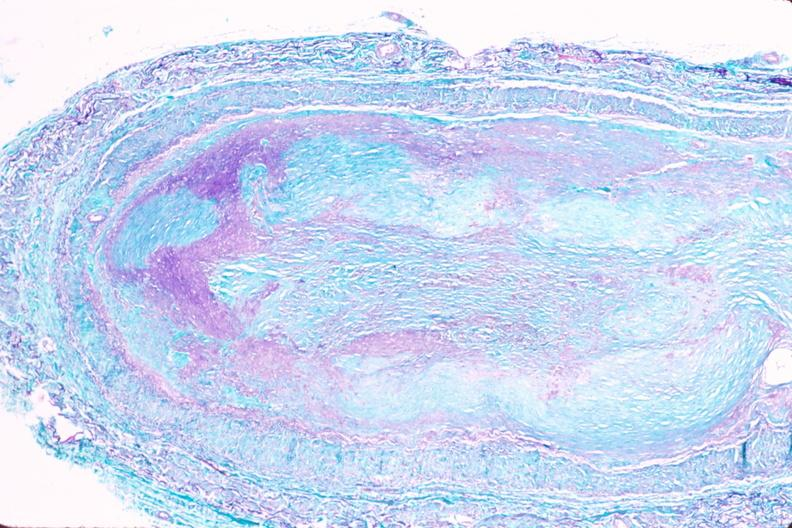where is this in?
Answer the question using a single word or phrase. In vasculature 